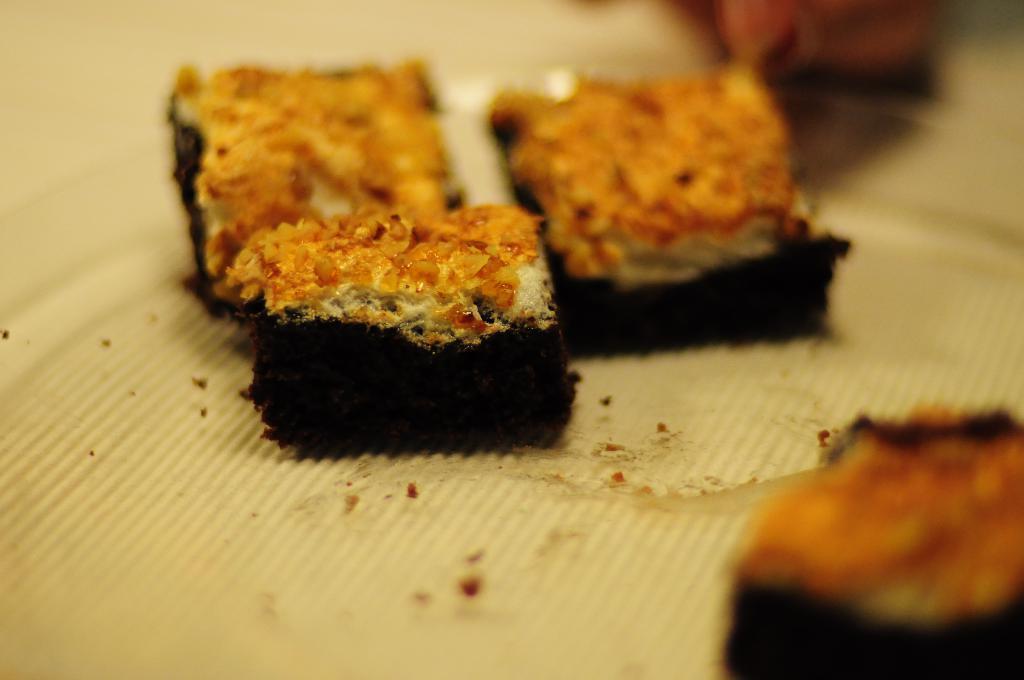How would you summarize this image in a sentence or two? In this image I can see some food items which looking like cake. These are placed on a white colored cloth. 